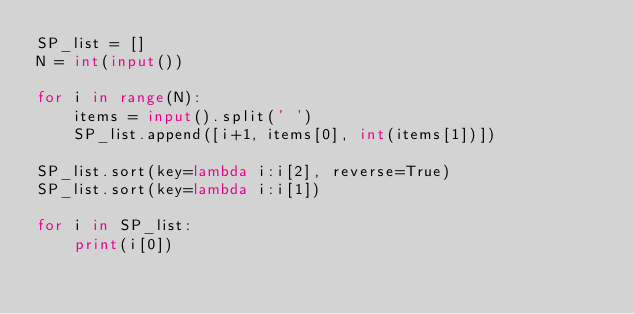Convert code to text. <code><loc_0><loc_0><loc_500><loc_500><_Python_>SP_list = []
N = int(input())

for i in range(N):
    items = input().split(' ')
    SP_list.append([i+1, items[0], int(items[1])])

SP_list.sort(key=lambda i:i[2], reverse=True)
SP_list.sort(key=lambda i:i[1])

for i in SP_list:
    print(i[0])</code> 